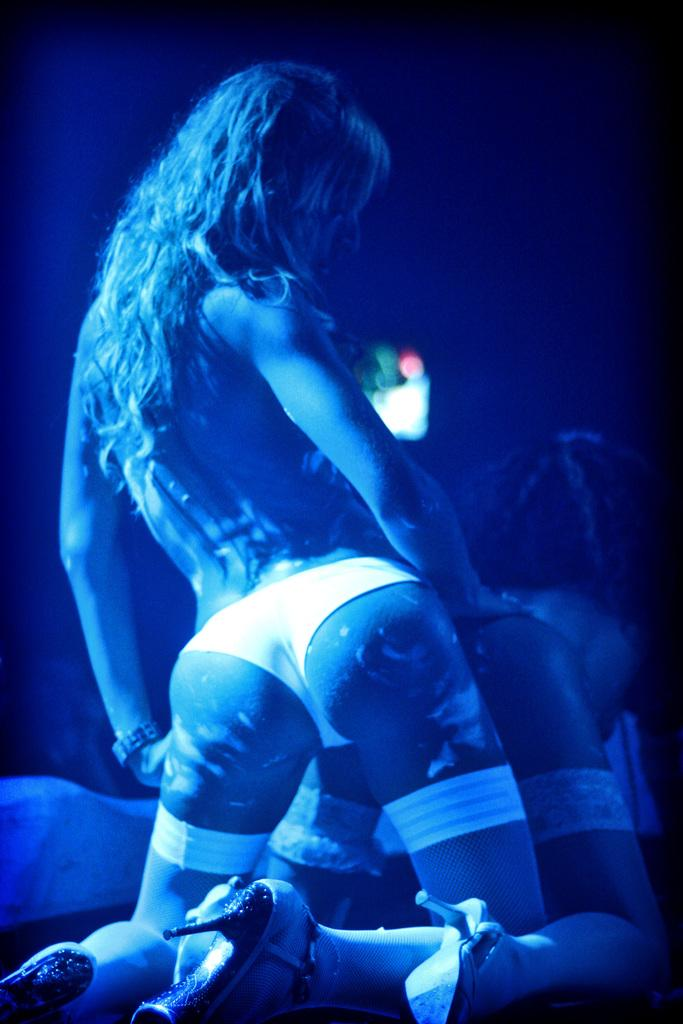How many people are in the image? There are two women in the image. What are the women wearing? The women are wearing clothes. What direction are the women facing in the image? The women are facing away from the camera. How would you describe the lighting in the image? The corners of the image are dark. Are there any slaves visible in the image? There is no mention of slaves in the image, and the term "slave" is not relevant to the content of the image. 